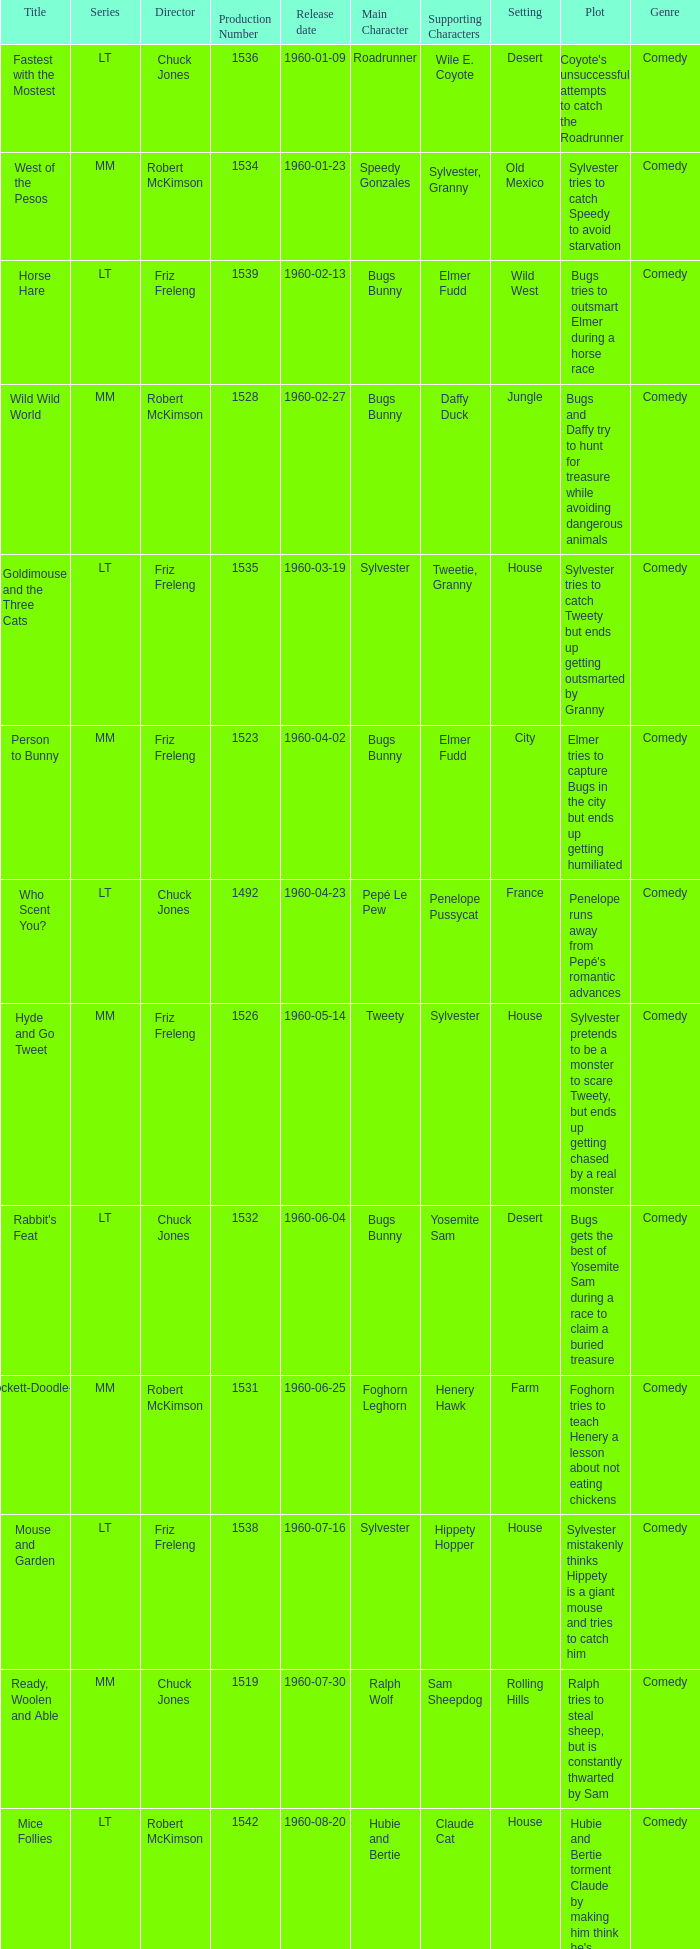Could you parse the entire table as a dict? {'header': ['Title', 'Series', 'Director', 'Production Number', 'Release date', 'Main Character', 'Supporting Characters', 'Setting', 'Plot', 'Genre'], 'rows': [['Fastest with the Mostest', 'LT', 'Chuck Jones', '1536', '1960-01-09', 'Roadrunner', 'Wile E. Coyote', 'Desert', "Coyote's unsuccessful attempts to catch the Roadrunner", 'Comedy'], ['West of the Pesos', 'MM', 'Robert McKimson', '1534', '1960-01-23', 'Speedy Gonzales', 'Sylvester, Granny', 'Old Mexico', 'Sylvester tries to catch Speedy to avoid starvation', 'Comedy'], ['Horse Hare', 'LT', 'Friz Freleng', '1539', '1960-02-13', 'Bugs Bunny', 'Elmer Fudd', 'Wild West', 'Bugs tries to outsmart Elmer during a horse race', 'Comedy'], ['Wild Wild World', 'MM', 'Robert McKimson', '1528', '1960-02-27', 'Bugs Bunny', 'Daffy Duck', 'Jungle', 'Bugs and Daffy try to hunt for treasure while avoiding dangerous animals', 'Comedy'], ['Goldimouse and the Three Cats', 'LT', 'Friz Freleng', '1535', '1960-03-19', 'Sylvester', 'Tweetie, Granny', 'House', 'Sylvester tries to catch Tweety but ends up getting outsmarted by Granny', 'Comedy'], ['Person to Bunny', 'MM', 'Friz Freleng', '1523', '1960-04-02', 'Bugs Bunny', 'Elmer Fudd', 'City', 'Elmer tries to capture Bugs in the city but ends up getting humiliated', 'Comedy'], ['Who Scent You?', 'LT', 'Chuck Jones', '1492', '1960-04-23', 'Pepé Le Pew', 'Penelope Pussycat', 'France', "Penelope runs away from Pepé's romantic advances", 'Comedy'], ['Hyde and Go Tweet', 'MM', 'Friz Freleng', '1526', '1960-05-14', 'Tweety', 'Sylvester', 'House', 'Sylvester pretends to be a monster to scare Tweety, but ends up getting chased by a real monster', 'Comedy'], ["Rabbit's Feat", 'LT', 'Chuck Jones', '1532', '1960-06-04', 'Bugs Bunny', 'Yosemite Sam', 'Desert', 'Bugs gets the best of Yosemite Sam during a race to claim a buried treasure', 'Comedy'], ['Crockett-Doodle-Do', 'MM', 'Robert McKimson', '1531', '1960-06-25', 'Foghorn Leghorn', 'Henery Hawk', 'Farm', 'Foghorn tries to teach Henery a lesson about not eating chickens', 'Comedy'], ['Mouse and Garden', 'LT', 'Friz Freleng', '1538', '1960-07-16', 'Sylvester', 'Hippety Hopper', 'House', 'Sylvester mistakenly thinks Hippety is a giant mouse and tries to catch him', 'Comedy'], ['Ready, Woolen and Able', 'MM', 'Chuck Jones', '1519', '1960-07-30', 'Ralph Wolf', 'Sam Sheepdog', 'Rolling Hills', 'Ralph tries to steal sheep, but is constantly thwarted by Sam', 'Comedy'], ['Mice Follies', 'LT', 'Robert McKimson', '1542', '1960-08-20', 'Hubie and Bertie', 'Claude Cat', 'House', "Hubie and Bertie torment Claude by making him think he's going crazy", 'Comedy'], ['From Hare to Heir', 'MM', 'Friz Freleng', '1548', '1960-09-03', 'Bugs Bunny', 'Yosemite Sam', 'Mansion', 'Bugs inherits a fortune but Yosemite Sam tries to steal it', 'Comedy'], ['The Dixie Fryer', 'MM', 'Robert McKimson', '1540', '1960-09-24', 'Foghorn Leghorn', 'Miss Prissy', 'Farm', 'Foghorn tries to get out of an arranged marriage to Miss Prissy', 'Comedy'], ['Hopalong Casualty', 'LT', 'Chuck Jones', '1545', '1960-10-08', 'Wile E. Coyote', 'Bugs Bunny', 'Desert', 'Wile E. Coyote tries to catch Bugs using various schemes', 'Comedy'], ['Trip For Tat', 'MM', 'Friz Freleng', '1541', '1960-10-29', 'Sylvester', 'Tweety', 'City', 'Sylvester and Tweety get trapped in a department store overnight', 'Comedy'], ['Dog Gone People', 'MM', 'Robert McKimson', '1547', '1960-11-12', 'Charlie Dog', 'Elmer Fudd', 'City', 'Charlie Dog tricks Elmer into taking him home, but becomes a nuisance', 'Comedy'], ['High Note', 'LT', 'Chuck Jones', '1480', '1960-12-03', 'Wile E. Coyote', 'Roadrunner', 'Desert', 'Wile E. Coyote tries various schemes to catch the Roadrunner', 'Comedy'], ['Lighter Than Hare', 'MM', 'Friz Freleng', '1533', '1960-12-17', 'Bugs Bunny', 'Yosemite Sam', 'Desert', 'Bugs outsmarts Yosemite Sam during a space mission', 'Comedy']]} What is the production number of From Hare to Heir? 1548.0. 